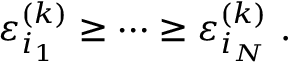Convert formula to latex. <formula><loc_0><loc_0><loc_500><loc_500>\varepsilon _ { i _ { 1 } } ^ { ( k ) } \geq \cdots \geq \varepsilon _ { i _ { N } } ^ { ( k ) } .</formula> 